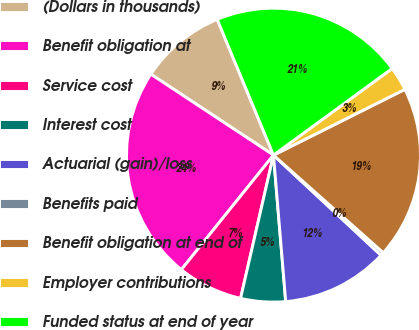<chart> <loc_0><loc_0><loc_500><loc_500><pie_chart><fcel>(Dollars in thousands)<fcel>Benefit obligation at<fcel>Service cost<fcel>Interest cost<fcel>Actuarial (gain)/loss<fcel>Benefits paid<fcel>Benefit obligation at end of<fcel>Employer contributions<fcel>Funded status at end of year<nl><fcel>9.46%<fcel>23.5%<fcel>7.19%<fcel>4.92%<fcel>11.74%<fcel>0.37%<fcel>18.95%<fcel>2.65%<fcel>21.22%<nl></chart> 